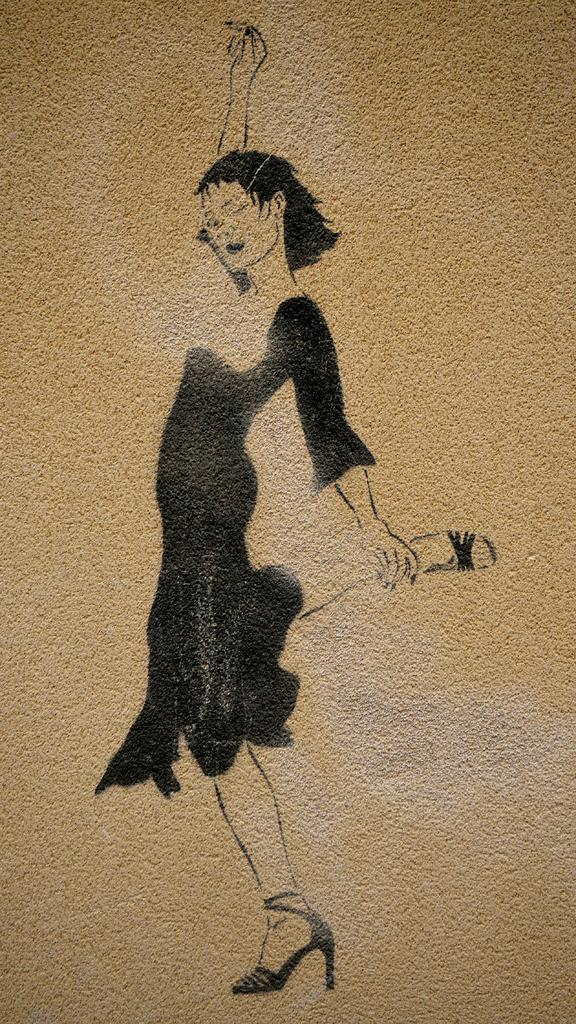What is depicted in the image? There is a painting of a woman in the image. What is the woman in the painting wearing on her feet? The woman in the painting is wearing sandals. What is the woman in the painting doing? The woman in the painting is standing. What type of juice is being served in the painting? There is no juice present in the painting; it features a woman standing and wearing sandals. 